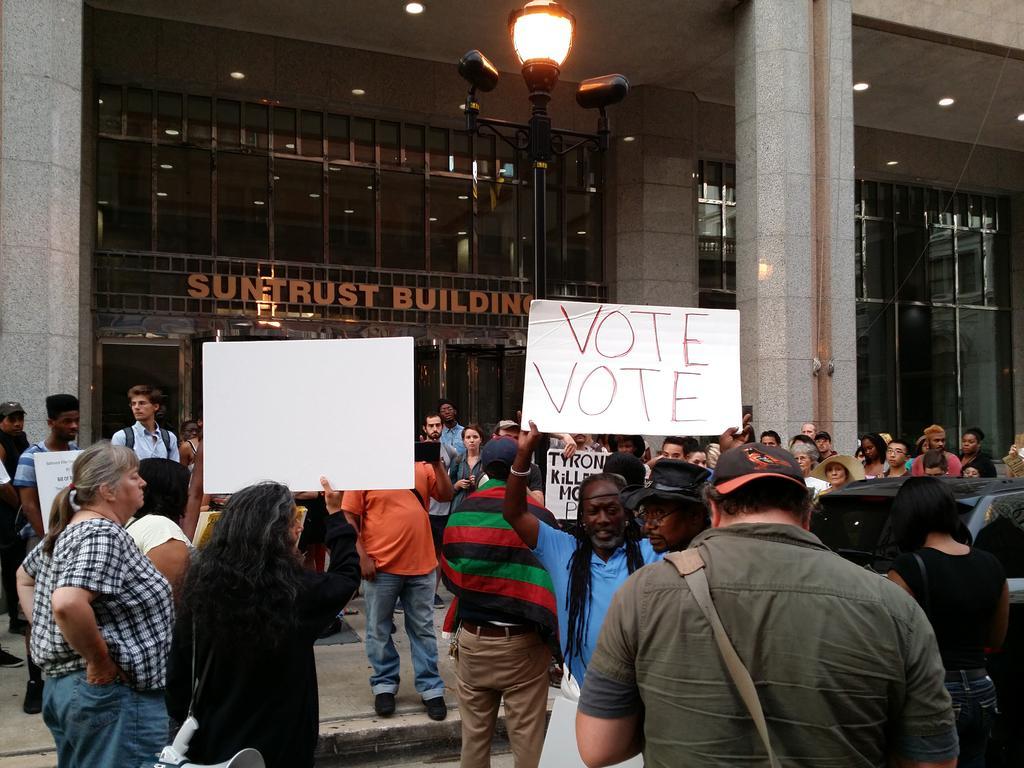In one or two sentences, can you explain what this image depicts? In this image, we can see some people and there is a building, we can see a light. 